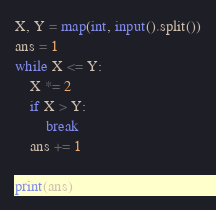Convert code to text. <code><loc_0><loc_0><loc_500><loc_500><_Python_>X, Y = map(int, input().split())
ans = 1
while X <= Y:
    X *= 2
    if X > Y:
        break
    ans += 1

print(ans)</code> 